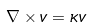Convert formula to latex. <formula><loc_0><loc_0><loc_500><loc_500>\nabla \times v = \kappa v</formula> 